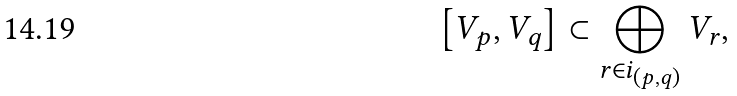<formula> <loc_0><loc_0><loc_500><loc_500>\left [ V _ { p } , V _ { q } \right ] \subset \bigoplus _ { r \in i _ { ( p , q ) } } V _ { r } ,</formula> 